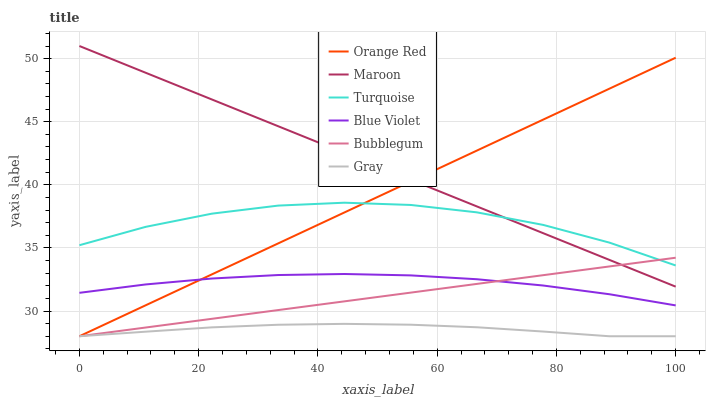Does Gray have the minimum area under the curve?
Answer yes or no. Yes. Does Maroon have the maximum area under the curve?
Answer yes or no. Yes. Does Turquoise have the minimum area under the curve?
Answer yes or no. No. Does Turquoise have the maximum area under the curve?
Answer yes or no. No. Is Maroon the smoothest?
Answer yes or no. Yes. Is Turquoise the roughest?
Answer yes or no. Yes. Is Bubblegum the smoothest?
Answer yes or no. No. Is Bubblegum the roughest?
Answer yes or no. No. Does Gray have the lowest value?
Answer yes or no. Yes. Does Turquoise have the lowest value?
Answer yes or no. No. Does Maroon have the highest value?
Answer yes or no. Yes. Does Turquoise have the highest value?
Answer yes or no. No. Is Gray less than Blue Violet?
Answer yes or no. Yes. Is Turquoise greater than Blue Violet?
Answer yes or no. Yes. Does Maroon intersect Orange Red?
Answer yes or no. Yes. Is Maroon less than Orange Red?
Answer yes or no. No. Is Maroon greater than Orange Red?
Answer yes or no. No. Does Gray intersect Blue Violet?
Answer yes or no. No. 